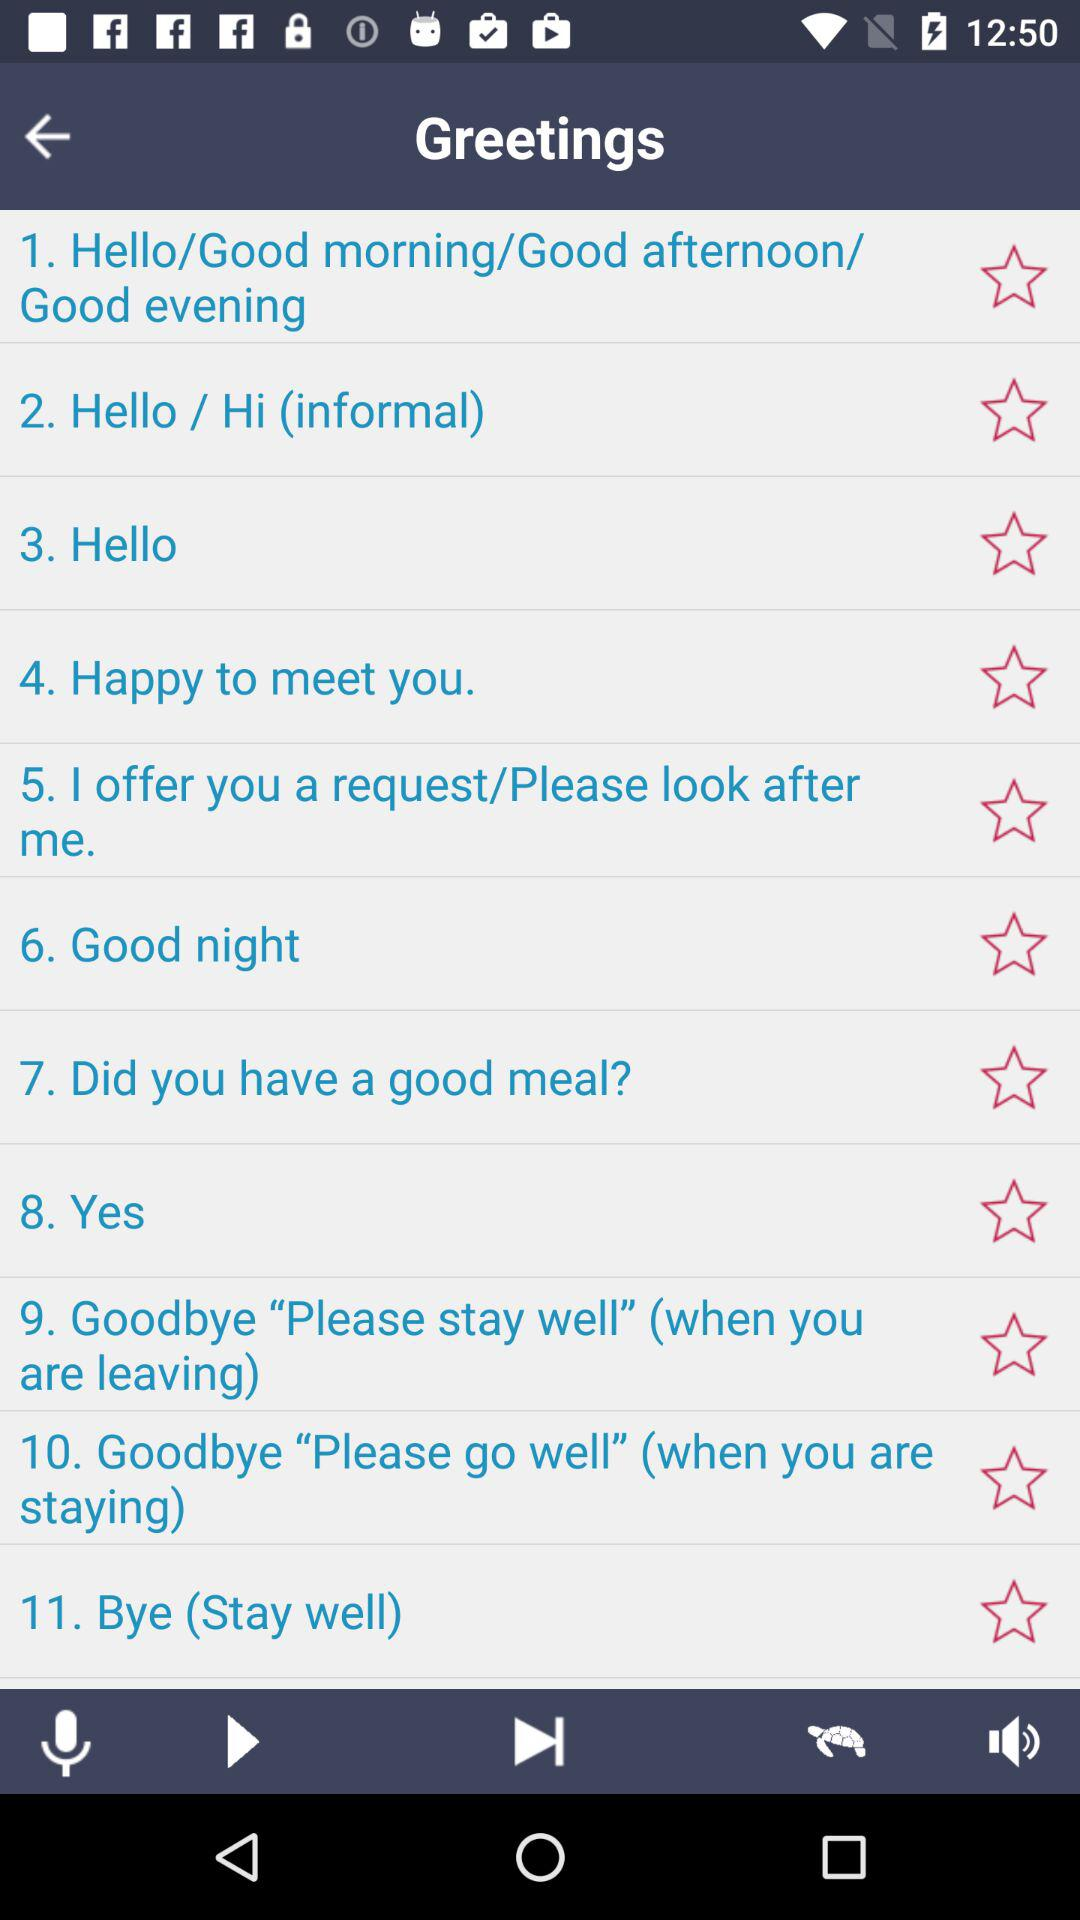What is the list of greetings shown? The list is "Hello/Good morning/Good afternoon Good evening", "Hello / Hi", "Hello", "Happy to meet you", "I offer you a request/Please look after me", "Good night", "Did you have a good meal?", "Yes", "Goodbye "Please stay well", "Goodbye "Please go well"", and "Bye". 